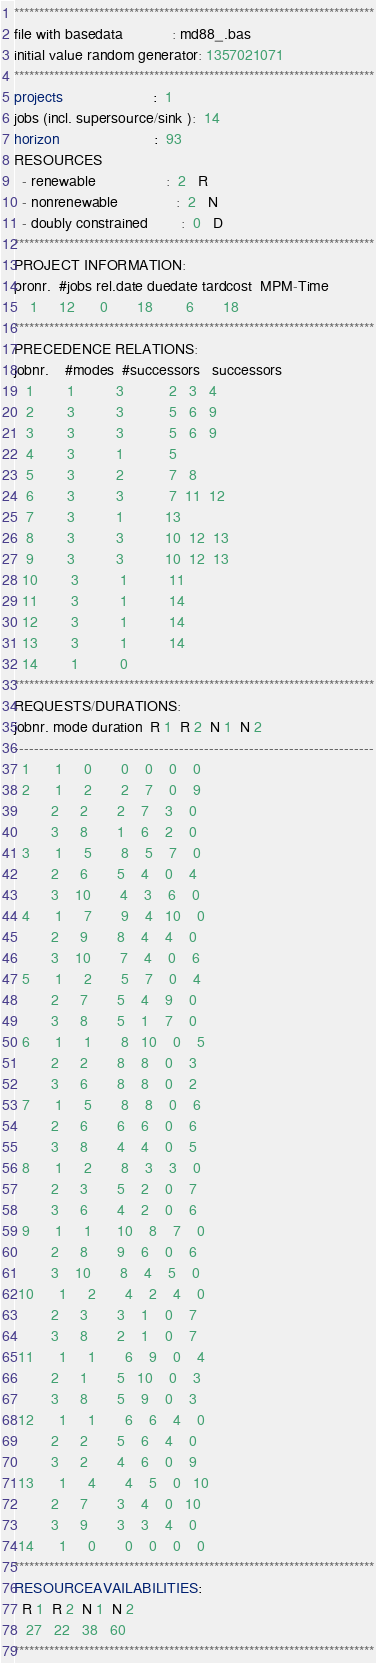<code> <loc_0><loc_0><loc_500><loc_500><_ObjectiveC_>************************************************************************
file with basedata            : md88_.bas
initial value random generator: 1357021071
************************************************************************
projects                      :  1
jobs (incl. supersource/sink ):  14
horizon                       :  93
RESOURCES
  - renewable                 :  2   R
  - nonrenewable              :  2   N
  - doubly constrained        :  0   D
************************************************************************
PROJECT INFORMATION:
pronr.  #jobs rel.date duedate tardcost  MPM-Time
    1     12      0       18        6       18
************************************************************************
PRECEDENCE RELATIONS:
jobnr.    #modes  #successors   successors
   1        1          3           2   3   4
   2        3          3           5   6   9
   3        3          3           5   6   9
   4        3          1           5
   5        3          2           7   8
   6        3          3           7  11  12
   7        3          1          13
   8        3          3          10  12  13
   9        3          3          10  12  13
  10        3          1          11
  11        3          1          14
  12        3          1          14
  13        3          1          14
  14        1          0        
************************************************************************
REQUESTS/DURATIONS:
jobnr. mode duration  R 1  R 2  N 1  N 2
------------------------------------------------------------------------
  1      1     0       0    0    0    0
  2      1     2       2    7    0    9
         2     2       2    7    3    0
         3     8       1    6    2    0
  3      1     5       8    5    7    0
         2     6       5    4    0    4
         3    10       4    3    6    0
  4      1     7       9    4   10    0
         2     9       8    4    4    0
         3    10       7    4    0    6
  5      1     2       5    7    0    4
         2     7       5    4    9    0
         3     8       5    1    7    0
  6      1     1       8   10    0    5
         2     2       8    8    0    3
         3     6       8    8    0    2
  7      1     5       8    8    0    6
         2     6       6    6    0    6
         3     8       4    4    0    5
  8      1     2       8    3    3    0
         2     3       5    2    0    7
         3     6       4    2    0    6
  9      1     1      10    8    7    0
         2     8       9    6    0    6
         3    10       8    4    5    0
 10      1     2       4    2    4    0
         2     3       3    1    0    7
         3     8       2    1    0    7
 11      1     1       6    9    0    4
         2     1       5   10    0    3
         3     8       5    9    0    3
 12      1     1       6    6    4    0
         2     2       5    6    4    0
         3     2       4    6    0    9
 13      1     4       4    5    0   10
         2     7       3    4    0   10
         3     9       3    3    4    0
 14      1     0       0    0    0    0
************************************************************************
RESOURCEAVAILABILITIES:
  R 1  R 2  N 1  N 2
   27   22   38   60
************************************************************************
</code> 